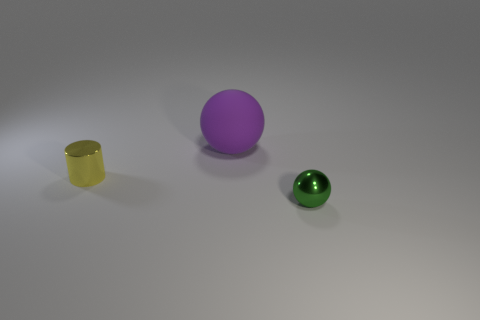Are there any other things that are the same size as the purple sphere?
Your response must be concise. No. What number of other objects are there of the same material as the cylinder?
Offer a very short reply. 1. What size is the yellow object in front of the large purple rubber ball on the right side of the small yellow cylinder?
Your answer should be very brief. Small. There is a sphere behind the tiny thing that is right of the small thing that is to the left of the tiny green metal sphere; what color is it?
Ensure brevity in your answer.  Purple. There is a object that is in front of the rubber ball and on the left side of the green shiny object; what size is it?
Provide a succinct answer. Small. What number of other things are there of the same shape as the big rubber object?
Your answer should be compact. 1. What number of spheres are either tiny green things or purple matte objects?
Provide a succinct answer. 2. Is there a tiny green shiny ball in front of the shiny thing behind the thing that is in front of the yellow metallic cylinder?
Give a very brief answer. Yes. What is the color of the other large matte thing that is the same shape as the green thing?
Provide a succinct answer. Purple. What number of purple things are either cylinders or big matte spheres?
Make the answer very short. 1. 